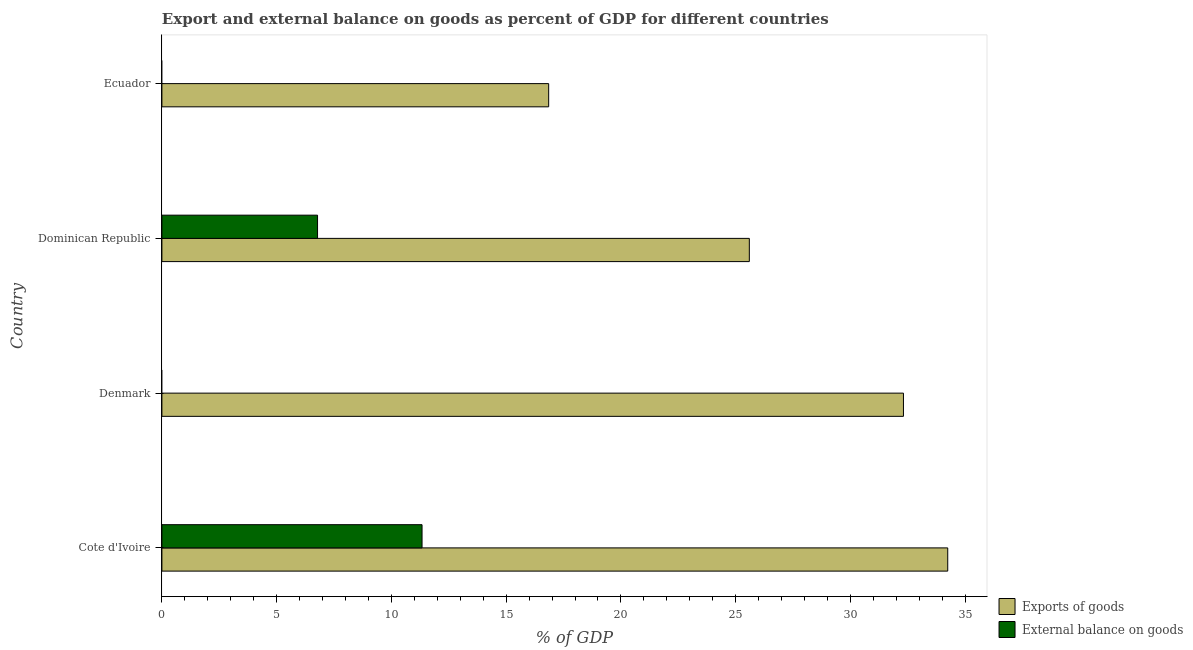Are the number of bars per tick equal to the number of legend labels?
Your response must be concise. No. What is the label of the 2nd group of bars from the top?
Your answer should be very brief. Dominican Republic. In how many cases, is the number of bars for a given country not equal to the number of legend labels?
Your answer should be very brief. 2. What is the export of goods as percentage of gdp in Dominican Republic?
Your answer should be very brief. 25.59. Across all countries, what is the maximum export of goods as percentage of gdp?
Ensure brevity in your answer.  34.24. Across all countries, what is the minimum external balance on goods as percentage of gdp?
Your response must be concise. 0. In which country was the export of goods as percentage of gdp maximum?
Your response must be concise. Cote d'Ivoire. What is the total export of goods as percentage of gdp in the graph?
Keep it short and to the point. 109. What is the difference between the export of goods as percentage of gdp in Cote d'Ivoire and that in Denmark?
Provide a succinct answer. 1.93. What is the difference between the export of goods as percentage of gdp in Ecuador and the external balance on goods as percentage of gdp in Denmark?
Keep it short and to the point. 16.85. What is the average export of goods as percentage of gdp per country?
Your response must be concise. 27.25. What is the difference between the export of goods as percentage of gdp and external balance on goods as percentage of gdp in Cote d'Ivoire?
Your response must be concise. 22.91. What is the ratio of the export of goods as percentage of gdp in Cote d'Ivoire to that in Ecuador?
Give a very brief answer. 2.03. Is the export of goods as percentage of gdp in Denmark less than that in Ecuador?
Offer a very short reply. No. Is the difference between the external balance on goods as percentage of gdp in Cote d'Ivoire and Dominican Republic greater than the difference between the export of goods as percentage of gdp in Cote d'Ivoire and Dominican Republic?
Provide a succinct answer. No. What is the difference between the highest and the second highest export of goods as percentage of gdp?
Ensure brevity in your answer.  1.93. What is the difference between the highest and the lowest export of goods as percentage of gdp?
Make the answer very short. 17.39. Are all the bars in the graph horizontal?
Ensure brevity in your answer.  Yes. How many countries are there in the graph?
Provide a short and direct response. 4. What is the difference between two consecutive major ticks on the X-axis?
Keep it short and to the point. 5. Are the values on the major ticks of X-axis written in scientific E-notation?
Make the answer very short. No. Does the graph contain any zero values?
Provide a succinct answer. Yes. Where does the legend appear in the graph?
Ensure brevity in your answer.  Bottom right. What is the title of the graph?
Offer a very short reply. Export and external balance on goods as percent of GDP for different countries. What is the label or title of the X-axis?
Ensure brevity in your answer.  % of GDP. What is the % of GDP of Exports of goods in Cote d'Ivoire?
Provide a succinct answer. 34.24. What is the % of GDP of External balance on goods in Cote d'Ivoire?
Offer a terse response. 11.34. What is the % of GDP of Exports of goods in Denmark?
Give a very brief answer. 32.31. What is the % of GDP of Exports of goods in Dominican Republic?
Offer a very short reply. 25.59. What is the % of GDP in External balance on goods in Dominican Republic?
Keep it short and to the point. 6.78. What is the % of GDP of Exports of goods in Ecuador?
Provide a short and direct response. 16.85. What is the % of GDP of External balance on goods in Ecuador?
Your response must be concise. 0. Across all countries, what is the maximum % of GDP in Exports of goods?
Provide a succinct answer. 34.24. Across all countries, what is the maximum % of GDP in External balance on goods?
Give a very brief answer. 11.34. Across all countries, what is the minimum % of GDP in Exports of goods?
Offer a very short reply. 16.85. Across all countries, what is the minimum % of GDP of External balance on goods?
Offer a very short reply. 0. What is the total % of GDP in Exports of goods in the graph?
Offer a very short reply. 109. What is the total % of GDP of External balance on goods in the graph?
Offer a very short reply. 18.12. What is the difference between the % of GDP of Exports of goods in Cote d'Ivoire and that in Denmark?
Your answer should be very brief. 1.93. What is the difference between the % of GDP of Exports of goods in Cote d'Ivoire and that in Dominican Republic?
Your answer should be compact. 8.64. What is the difference between the % of GDP in External balance on goods in Cote d'Ivoire and that in Dominican Republic?
Make the answer very short. 4.55. What is the difference between the % of GDP of Exports of goods in Cote d'Ivoire and that in Ecuador?
Provide a short and direct response. 17.39. What is the difference between the % of GDP in Exports of goods in Denmark and that in Dominican Republic?
Make the answer very short. 6.72. What is the difference between the % of GDP in Exports of goods in Denmark and that in Ecuador?
Ensure brevity in your answer.  15.46. What is the difference between the % of GDP in Exports of goods in Dominican Republic and that in Ecuador?
Give a very brief answer. 8.74. What is the difference between the % of GDP of Exports of goods in Cote d'Ivoire and the % of GDP of External balance on goods in Dominican Republic?
Ensure brevity in your answer.  27.46. What is the difference between the % of GDP of Exports of goods in Denmark and the % of GDP of External balance on goods in Dominican Republic?
Your answer should be compact. 25.53. What is the average % of GDP in Exports of goods per country?
Ensure brevity in your answer.  27.25. What is the average % of GDP in External balance on goods per country?
Offer a very short reply. 4.53. What is the difference between the % of GDP in Exports of goods and % of GDP in External balance on goods in Cote d'Ivoire?
Provide a short and direct response. 22.9. What is the difference between the % of GDP of Exports of goods and % of GDP of External balance on goods in Dominican Republic?
Your answer should be compact. 18.81. What is the ratio of the % of GDP in Exports of goods in Cote d'Ivoire to that in Denmark?
Offer a terse response. 1.06. What is the ratio of the % of GDP in Exports of goods in Cote d'Ivoire to that in Dominican Republic?
Your answer should be very brief. 1.34. What is the ratio of the % of GDP in External balance on goods in Cote d'Ivoire to that in Dominican Republic?
Offer a very short reply. 1.67. What is the ratio of the % of GDP in Exports of goods in Cote d'Ivoire to that in Ecuador?
Offer a terse response. 2.03. What is the ratio of the % of GDP of Exports of goods in Denmark to that in Dominican Republic?
Provide a succinct answer. 1.26. What is the ratio of the % of GDP of Exports of goods in Denmark to that in Ecuador?
Ensure brevity in your answer.  1.92. What is the ratio of the % of GDP in Exports of goods in Dominican Republic to that in Ecuador?
Your answer should be compact. 1.52. What is the difference between the highest and the second highest % of GDP of Exports of goods?
Ensure brevity in your answer.  1.93. What is the difference between the highest and the lowest % of GDP in Exports of goods?
Offer a very short reply. 17.39. What is the difference between the highest and the lowest % of GDP in External balance on goods?
Ensure brevity in your answer.  11.34. 